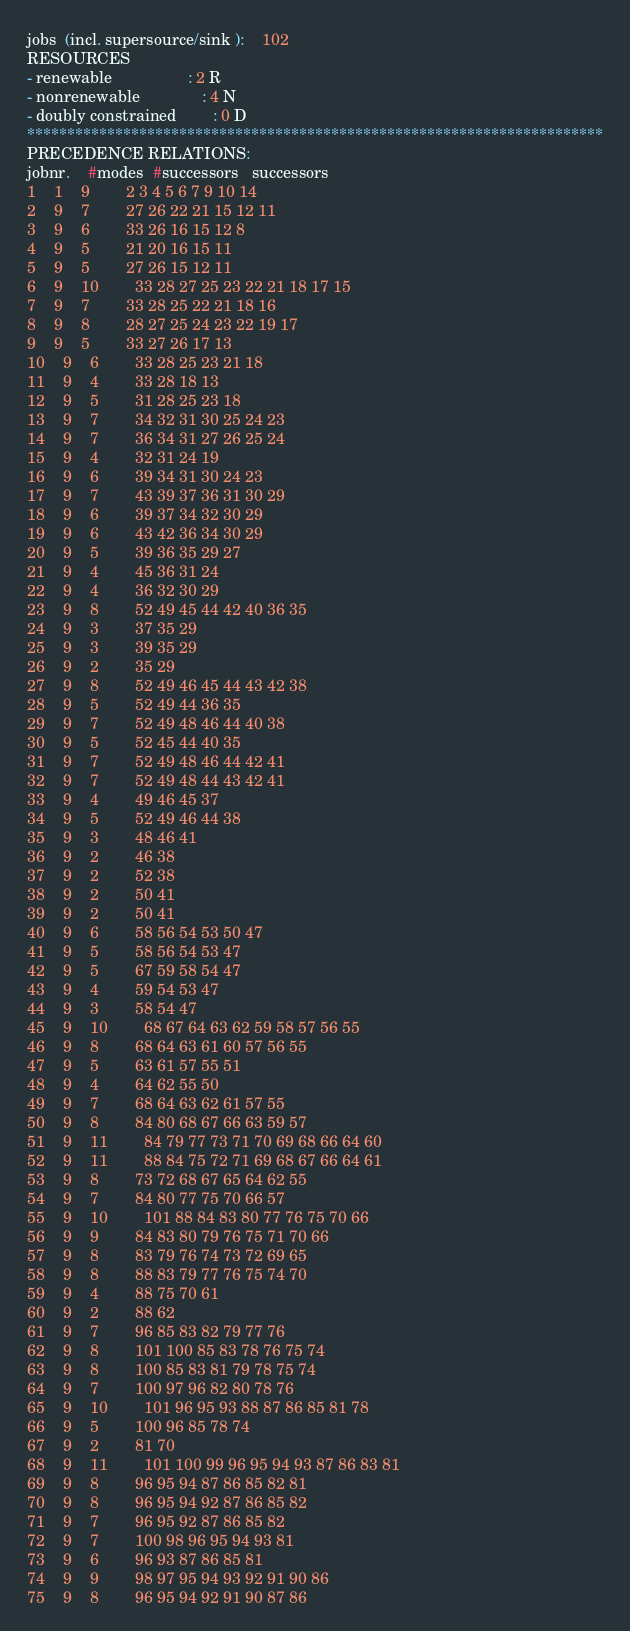<code> <loc_0><loc_0><loc_500><loc_500><_ObjectiveC_>jobs  (incl. supersource/sink ):	102
RESOURCES
- renewable                 : 2 R
- nonrenewable              : 4 N
- doubly constrained        : 0 D
************************************************************************
PRECEDENCE RELATIONS:
jobnr.    #modes  #successors   successors
1	1	9		2 3 4 5 6 7 9 10 14 
2	9	7		27 26 22 21 15 12 11 
3	9	6		33 26 16 15 12 8 
4	9	5		21 20 16 15 11 
5	9	5		27 26 15 12 11 
6	9	10		33 28 27 25 23 22 21 18 17 15 
7	9	7		33 28 25 22 21 18 16 
8	9	8		28 27 25 24 23 22 19 17 
9	9	5		33 27 26 17 13 
10	9	6		33 28 25 23 21 18 
11	9	4		33 28 18 13 
12	9	5		31 28 25 23 18 
13	9	7		34 32 31 30 25 24 23 
14	9	7		36 34 31 27 26 25 24 
15	9	4		32 31 24 19 
16	9	6		39 34 31 30 24 23 
17	9	7		43 39 37 36 31 30 29 
18	9	6		39 37 34 32 30 29 
19	9	6		43 42 36 34 30 29 
20	9	5		39 36 35 29 27 
21	9	4		45 36 31 24 
22	9	4		36 32 30 29 
23	9	8		52 49 45 44 42 40 36 35 
24	9	3		37 35 29 
25	9	3		39 35 29 
26	9	2		35 29 
27	9	8		52 49 46 45 44 43 42 38 
28	9	5		52 49 44 36 35 
29	9	7		52 49 48 46 44 40 38 
30	9	5		52 45 44 40 35 
31	9	7		52 49 48 46 44 42 41 
32	9	7		52 49 48 44 43 42 41 
33	9	4		49 46 45 37 
34	9	5		52 49 46 44 38 
35	9	3		48 46 41 
36	9	2		46 38 
37	9	2		52 38 
38	9	2		50 41 
39	9	2		50 41 
40	9	6		58 56 54 53 50 47 
41	9	5		58 56 54 53 47 
42	9	5		67 59 58 54 47 
43	9	4		59 54 53 47 
44	9	3		58 54 47 
45	9	10		68 67 64 63 62 59 58 57 56 55 
46	9	8		68 64 63 61 60 57 56 55 
47	9	5		63 61 57 55 51 
48	9	4		64 62 55 50 
49	9	7		68 64 63 62 61 57 55 
50	9	8		84 80 68 67 66 63 59 57 
51	9	11		84 79 77 73 71 70 69 68 66 64 60 
52	9	11		88 84 75 72 71 69 68 67 66 64 61 
53	9	8		73 72 68 67 65 64 62 55 
54	9	7		84 80 77 75 70 66 57 
55	9	10		101 88 84 83 80 77 76 75 70 66 
56	9	9		84 83 80 79 76 75 71 70 66 
57	9	8		83 79 76 74 73 72 69 65 
58	9	8		88 83 79 77 76 75 74 70 
59	9	4		88 75 70 61 
60	9	2		88 62 
61	9	7		96 85 83 82 79 77 76 
62	9	8		101 100 85 83 78 76 75 74 
63	9	8		100 85 83 81 79 78 75 74 
64	9	7		100 97 96 82 80 78 76 
65	9	10		101 96 95 93 88 87 86 85 81 78 
66	9	5		100 96 85 78 74 
67	9	2		81 70 
68	9	11		101 100 99 96 95 94 93 87 86 83 81 
69	9	8		96 95 94 87 86 85 82 81 
70	9	8		96 95 94 92 87 86 85 82 
71	9	7		96 95 92 87 86 85 82 
72	9	7		100 98 96 95 94 93 81 
73	9	6		96 93 87 86 85 81 
74	9	9		98 97 95 94 93 92 91 90 86 
75	9	8		96 95 94 92 91 90 87 86 </code> 